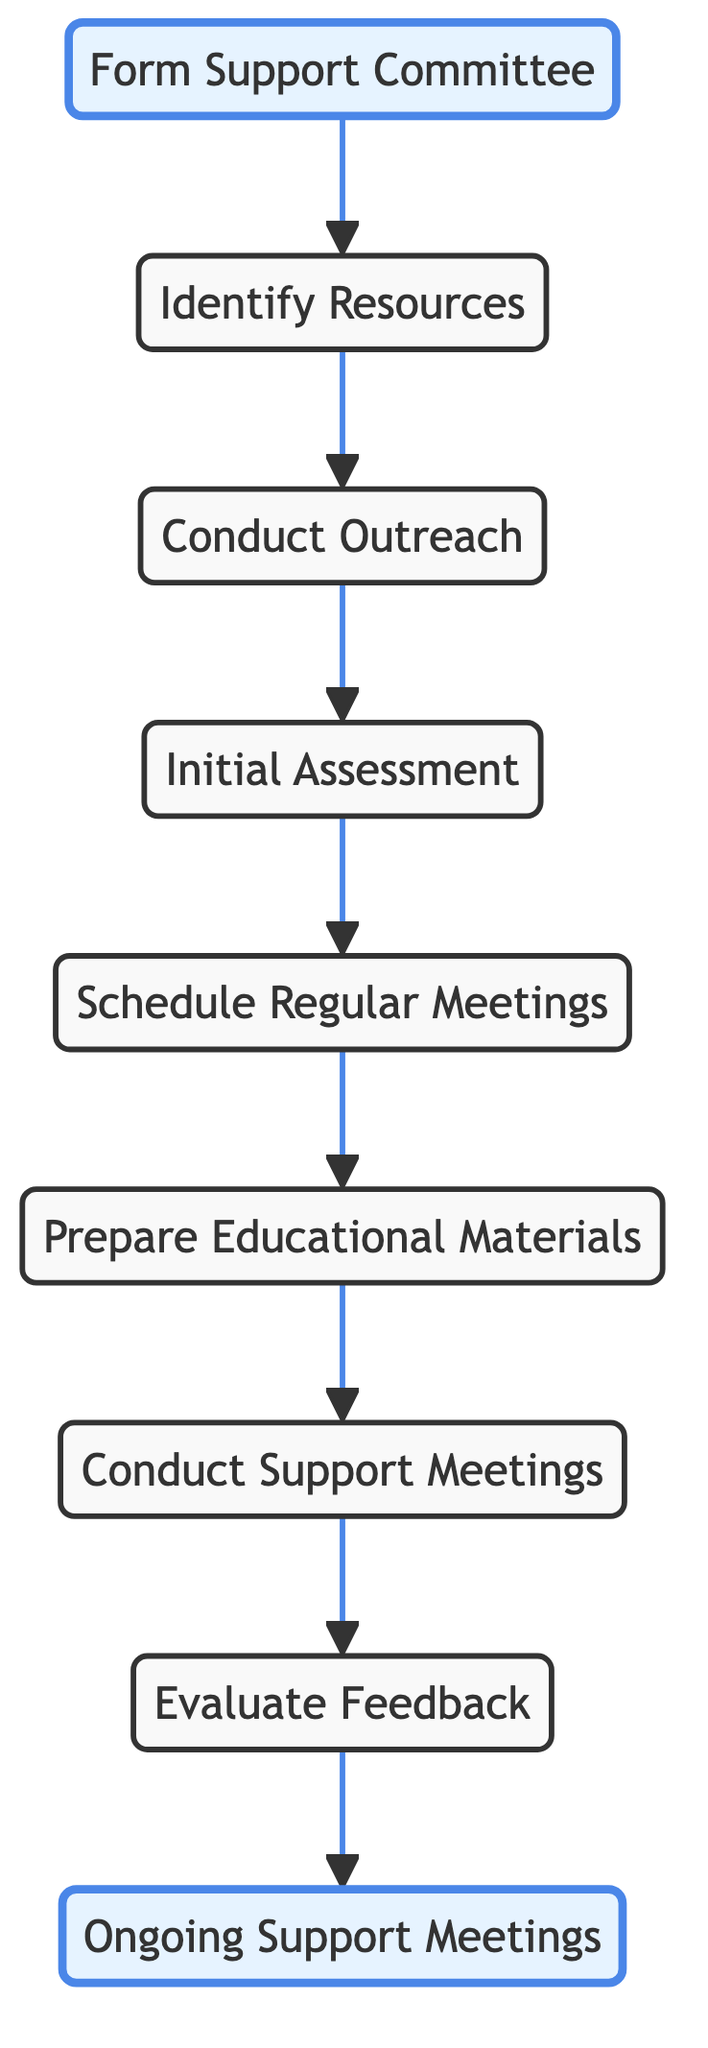What is the first step in the flowchart? The first step is represented by the node "Form Support Committee," which initiates the flow of the process.
Answer: Form Support Committee How many nodes are in the flowchart? The flowchart has a total of 8 nodes representing different steps in the veterans' support process.
Answer: 8 What comes after "Conduct Outreach"? The node that comes after "Conduct Outreach" is "Initial Assessment," indicating the next step in the process.
Answer: Initial Assessment What is the final step in the flowchart? The final step is indicated by "Ongoing Support Meetings," which represents the conclusion of the process and continuous support for veterans.
Answer: Ongoing Support Meetings From which node does "Evaluate Feedback" flow to? "Evaluate Feedback" flows to "Ongoing Support Meetings," showing that feedback is evaluated before continuing support.
Answer: Ongoing Support Meetings How many steps are there between "Form Support Committee" and "Conduct Support Meetings"? There are 6 steps between "Form Support Committee" and "Conduct Support Meetings," as each step flows to the next in the sequence.
Answer: 6 Which node is immediately before "Prepare Educational Materials"? The node immediately before "Prepare Educational Materials" is "Schedule Regular Meetings," which is the preceding step in the process.
Answer: Schedule Regular Meetings What is the purpose of the "Initial Assessment" node? The purpose of the "Initial Assessment" node is to evaluate veterans' needs and identify key areas of support necessary for their assistance.
Answer: Evaluate veterans' needs What action follows "Conduct Support Meetings"? The action that follows "Conduct Support Meetings" is "Evaluate Feedback," highlighting the focus on gathering feedback after meetings.
Answer: Evaluate Feedback 